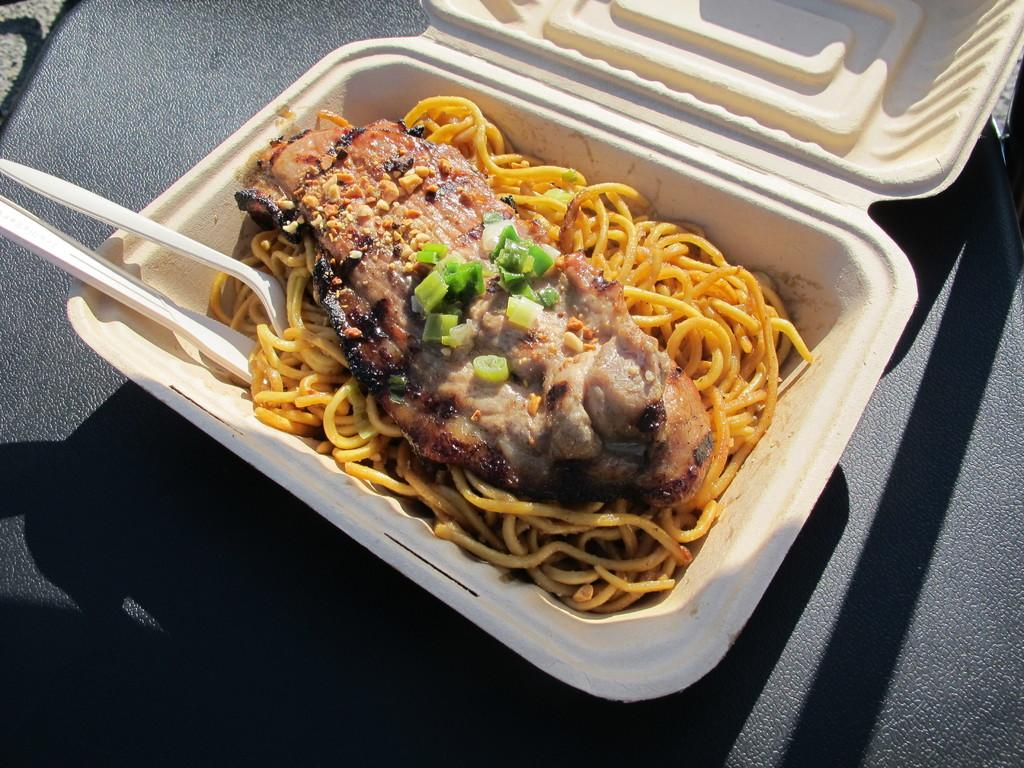What is the color of the box in the image? The box in the image is white. What is inside the box? The box contains food. What utensils are visible in the image? There are spoons in the image. What can be inferred about the location of the image based on the background? The background of the image appears to be a seat. How many credits are required to purchase the food in the box? There is no mention of credits or any form of currency in the image, so it cannot be determined. 